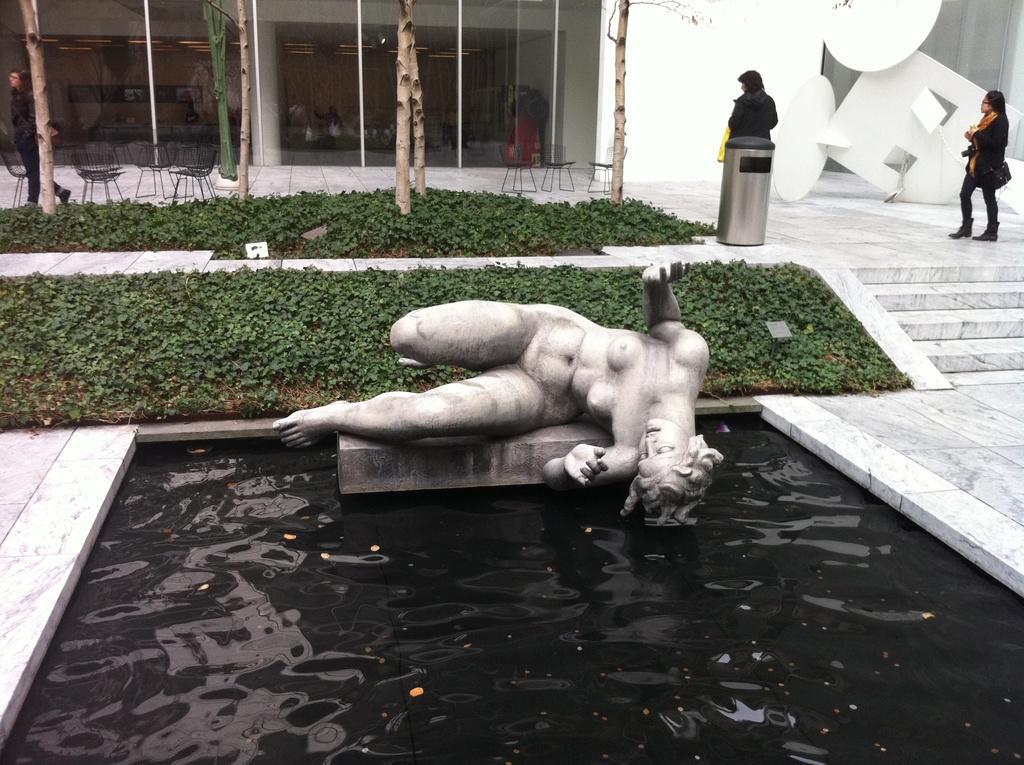In one or two sentences, can you explain what this image depicts? In the middle of this image, there is a statue of a nude woman, lying on a platform. This platform is in the water pond. In the background, there are two persons on the floor, on which there is a dustbin, there are trees, plants and there are chairs arranged, and there is a building which is having glass windows and a white wall. 